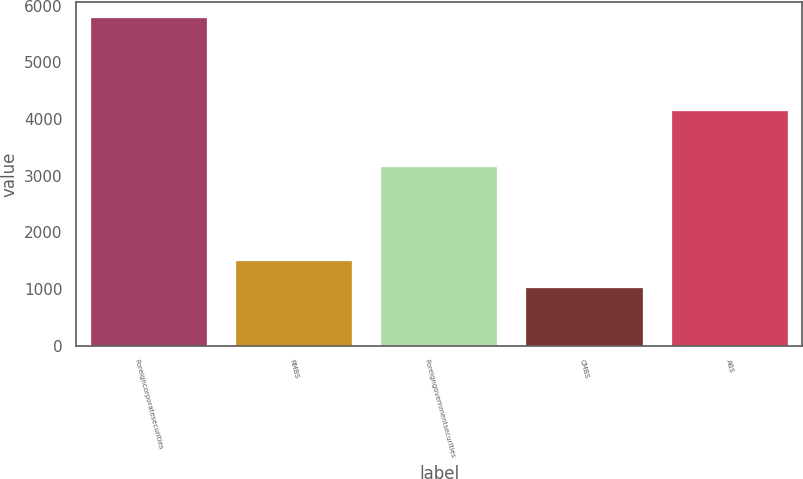<chart> <loc_0><loc_0><loc_500><loc_500><bar_chart><fcel>Foreigncorporatesecurities<fcel>RMBS<fcel>Foreigngovernmentsecurities<fcel>CMBS<fcel>ABS<nl><fcel>5777<fcel>1487.6<fcel>3159<fcel>1011<fcel>4148<nl></chart> 